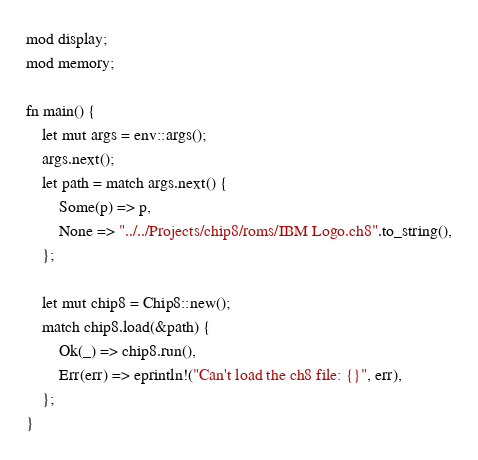<code> <loc_0><loc_0><loc_500><loc_500><_Rust_>mod display;
mod memory;

fn main() {
    let mut args = env::args();
    args.next();
    let path = match args.next() {
        Some(p) => p,
        None => "../../Projects/chip8/roms/IBM Logo.ch8".to_string(),
    };

    let mut chip8 = Chip8::new();
    match chip8.load(&path) {
        Ok(_) => chip8.run(),
        Err(err) => eprintln!("Can't load the ch8 file: {}", err),
    };
}
</code> 